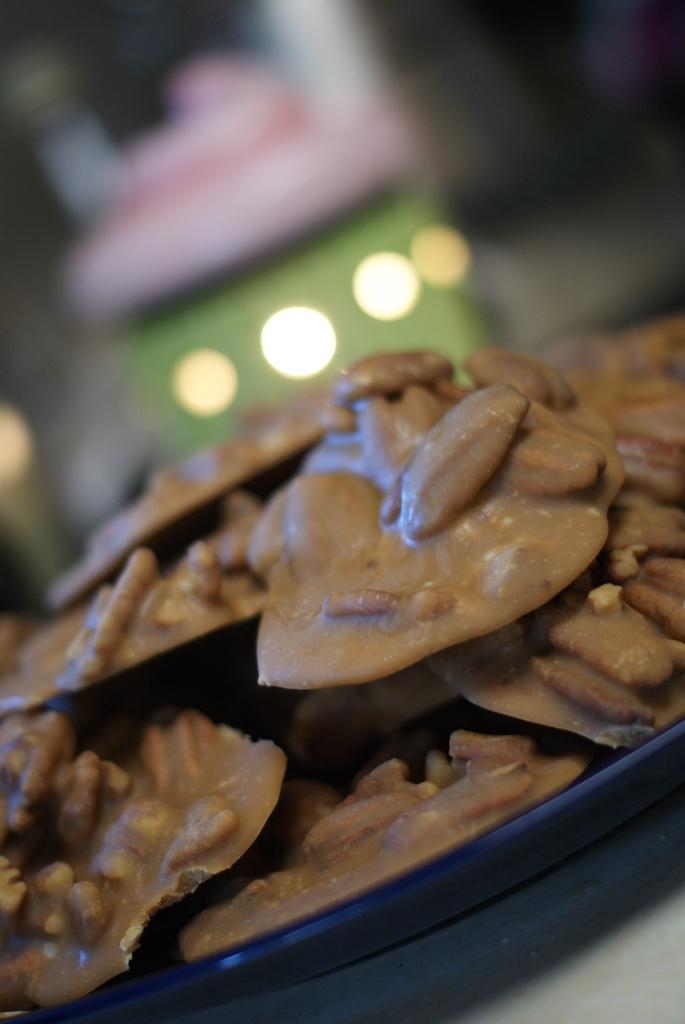What types of items can be seen in the image? There are food items in the image. Where are the food items located? The food items are placed on a surface. How many frogs can be seen interacting with the food items in the image? There are no frogs present in the image, so it is not possible to determine how many frogs might be interacting with the food items. 